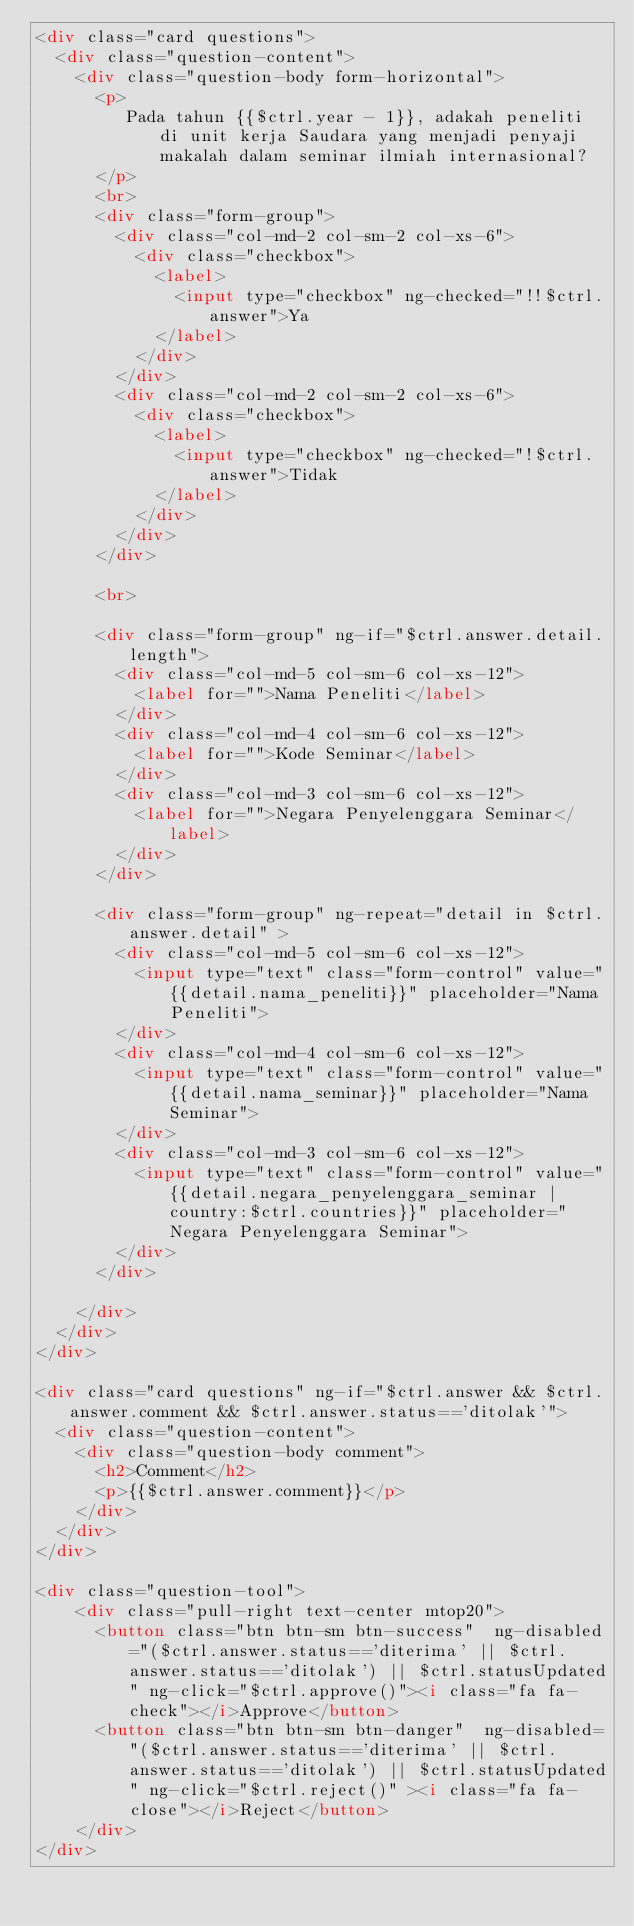Convert code to text. <code><loc_0><loc_0><loc_500><loc_500><_HTML_><div class="card questions">
  <div class="question-content">
    <div class="question-body form-horizontal">
      <p>
         Pada tahun {{$ctrl.year - 1}}, adakah peneliti di unit kerja Saudara yang menjadi penyaji makalah dalam seminar ilmiah internasional?
      </p>
      <br>
      <div class="form-group">
        <div class="col-md-2 col-sm-2 col-xs-6">
          <div class="checkbox">
            <label>
              <input type="checkbox" ng-checked="!!$ctrl.answer">Ya
            </label>
          </div>
        </div>
        <div class="col-md-2 col-sm-2 col-xs-6">
          <div class="checkbox">
            <label>
              <input type="checkbox" ng-checked="!$ctrl.answer">Tidak
            </label>
          </div>
        </div>
      </div>

      <br>

      <div class="form-group" ng-if="$ctrl.answer.detail.length">
        <div class="col-md-5 col-sm-6 col-xs-12">
          <label for="">Nama Peneliti</label>
        </div>
        <div class="col-md-4 col-sm-6 col-xs-12">
          <label for="">Kode Seminar</label>
        </div>
        <div class="col-md-3 col-sm-6 col-xs-12">
          <label for="">Negara Penyelenggara Seminar</label>
        </div>
      </div>

      <div class="form-group" ng-repeat="detail in $ctrl.answer.detail" >
        <div class="col-md-5 col-sm-6 col-xs-12">
          <input type="text" class="form-control" value="{{detail.nama_peneliti}}" placeholder="Nama Peneliti">
        </div>
        <div class="col-md-4 col-sm-6 col-xs-12">
          <input type="text" class="form-control" value="{{detail.nama_seminar}}" placeholder="Nama Seminar">
        </div>
        <div class="col-md-3 col-sm-6 col-xs-12">
          <input type="text" class="form-control" value="{{detail.negara_penyelenggara_seminar | country:$ctrl.countries}}" placeholder="Negara Penyelenggara Seminar">
        </div>
      </div>

    </div>
  </div>
</div>

<div class="card questions" ng-if="$ctrl.answer && $ctrl.answer.comment && $ctrl.answer.status=='ditolak'">
  <div class="question-content">
    <div class="question-body comment">
      <h2>Comment</h2>
      <p>{{$ctrl.answer.comment}}</p>
    </div>
  </div>
</div>

<div class="question-tool">
    <div class="pull-right text-center mtop20">
      <button class="btn btn-sm btn-success"  ng-disabled="($ctrl.answer.status=='diterima' || $ctrl.answer.status=='ditolak') || $ctrl.statusUpdated" ng-click="$ctrl.approve()"><i class="fa fa-check"></i>Approve</button>
      <button class="btn btn-sm btn-danger"  ng-disabled="($ctrl.answer.status=='diterima' || $ctrl.answer.status=='ditolak') || $ctrl.statusUpdated" ng-click="$ctrl.reject()" ><i class="fa fa-close"></i>Reject</button>
    </div>
</div>
</code> 